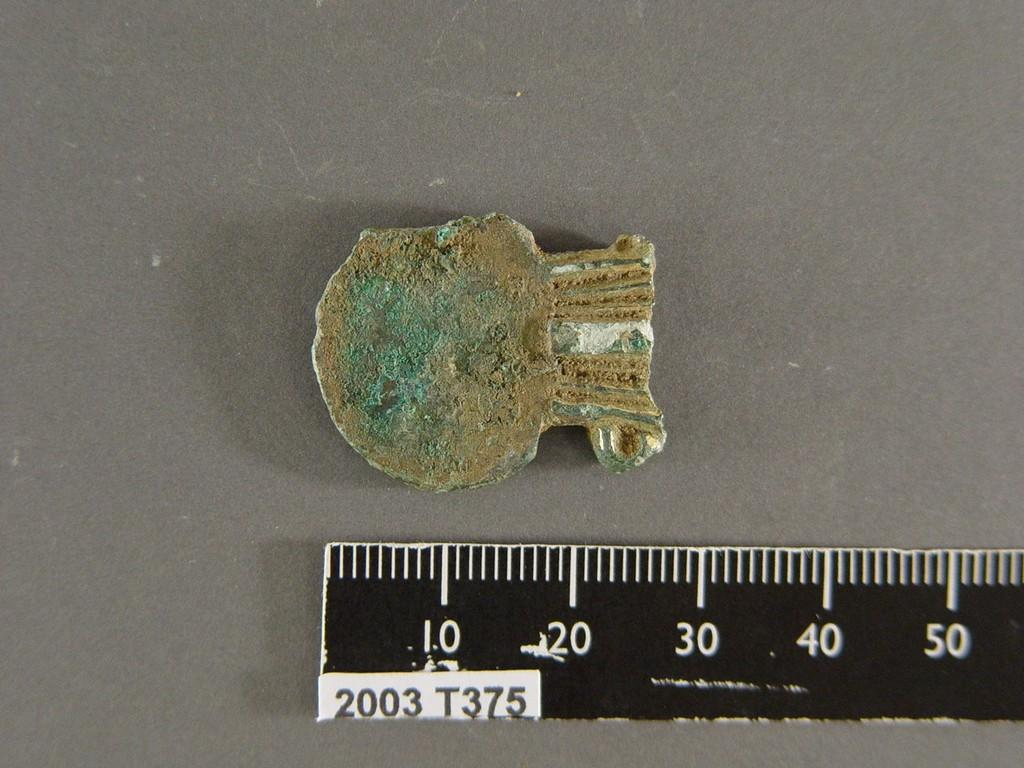<image>
Relay a brief, clear account of the picture shown. A ruler has a label that says 2003 T375 